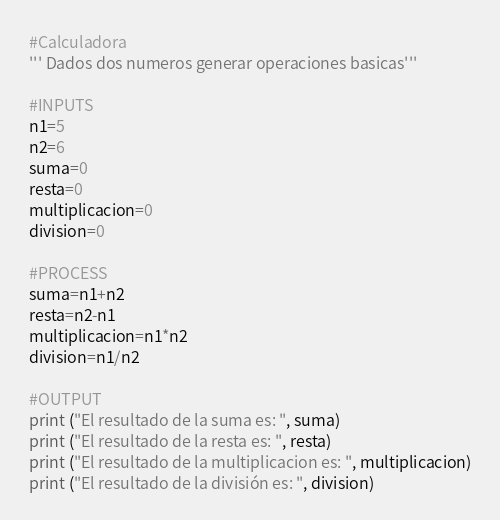Convert code to text. <code><loc_0><loc_0><loc_500><loc_500><_Python_>#Calculadora
''' Dados dos numeros generar operaciones basicas'''

#INPUTS
n1=5
n2=6
suma=0
resta=0
multiplicacion=0
division=0

#PROCESS
suma=n1+n2
resta=n2-n1
multiplicacion=n1*n2
division=n1/n2

#OUTPUT
print ("El resultado de la suma es: ", suma)
print ("El resultado de la resta es: ", resta)
print ("El resultado de la multiplicacion es: ", multiplicacion)
print ("El resultado de la división es: ", division)
</code> 